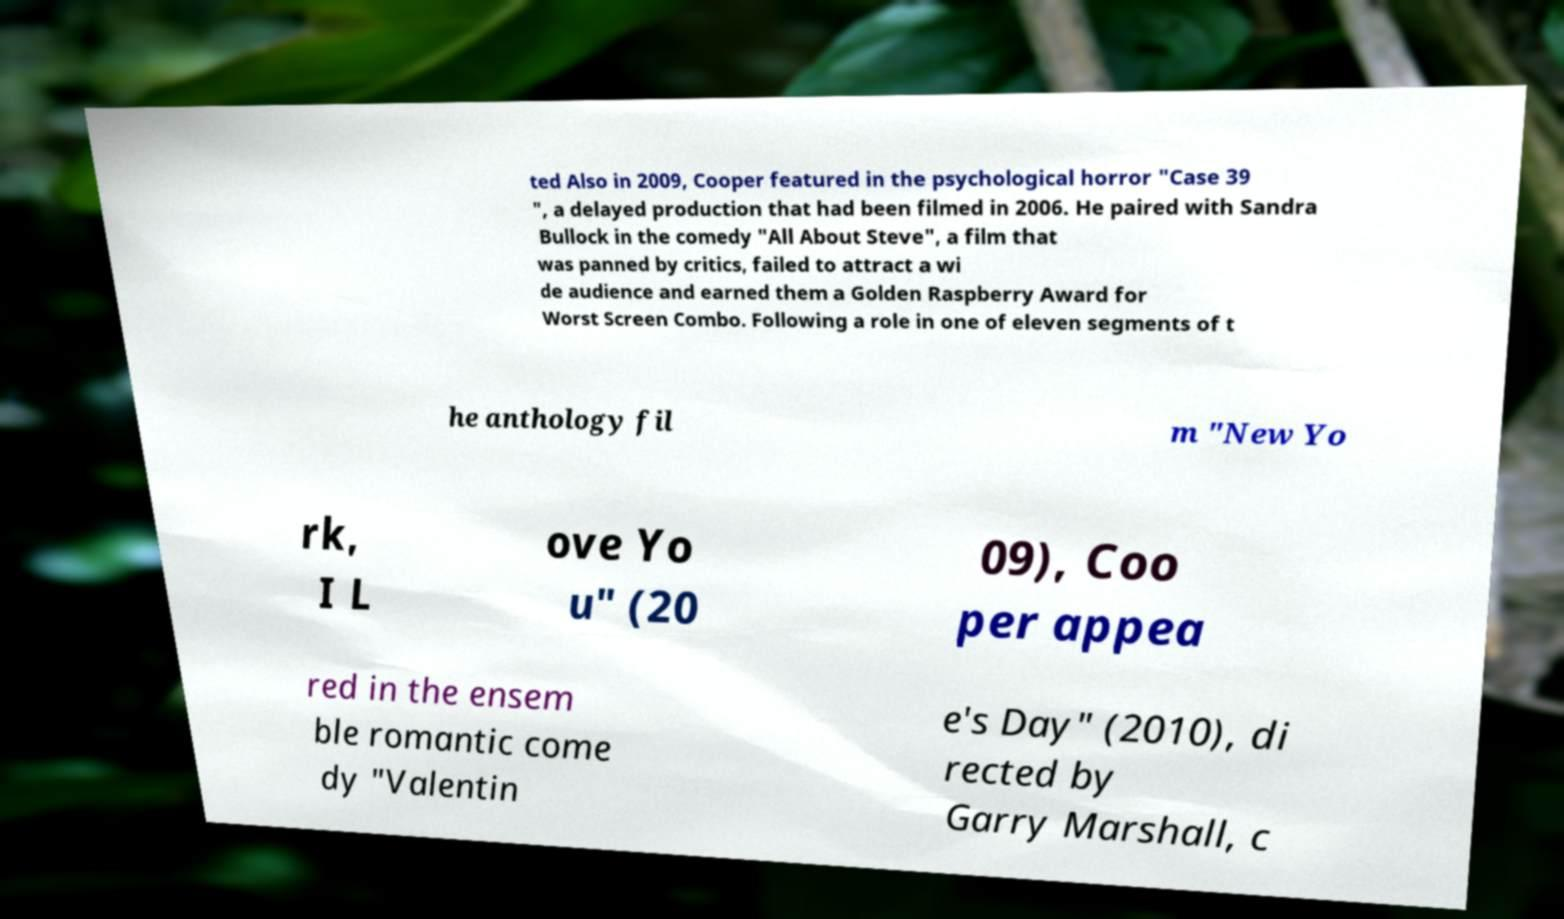Could you extract and type out the text from this image? ted Also in 2009, Cooper featured in the psychological horror "Case 39 ", a delayed production that had been filmed in 2006. He paired with Sandra Bullock in the comedy "All About Steve", a film that was panned by critics, failed to attract a wi de audience and earned them a Golden Raspberry Award for Worst Screen Combo. Following a role in one of eleven segments of t he anthology fil m "New Yo rk, I L ove Yo u" (20 09), Coo per appea red in the ensem ble romantic come dy "Valentin e's Day" (2010), di rected by Garry Marshall, c 